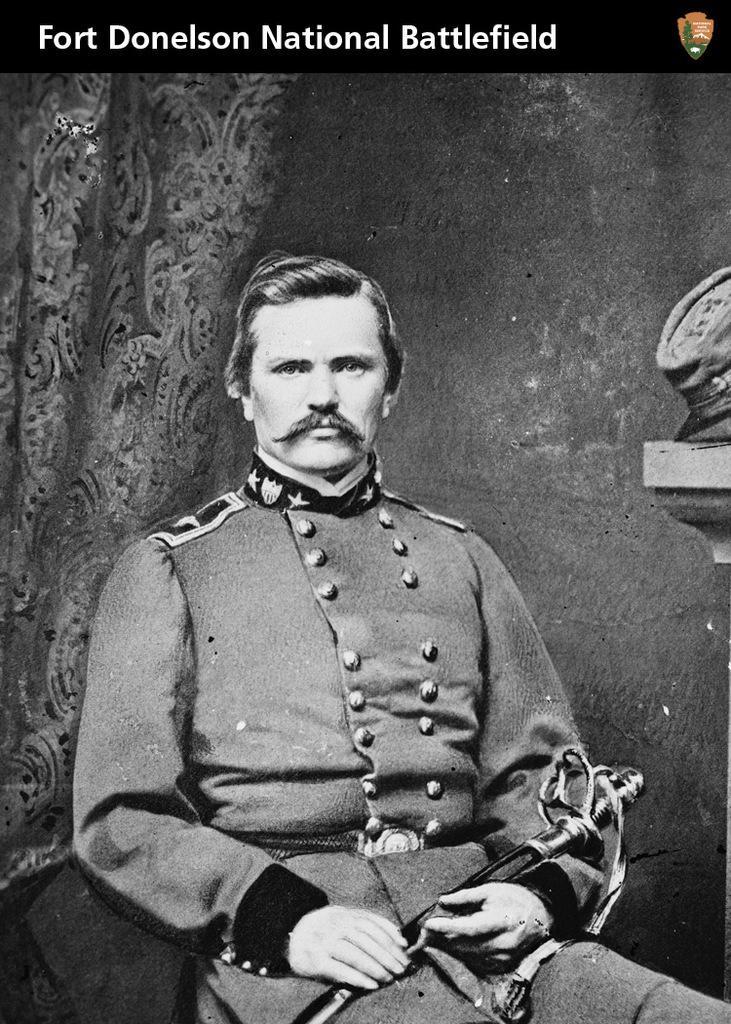Describe this image in one or two sentences. This is an black and white poster of a man. He wore a uniform. This man holds a sword. This poster is titled as "Fort Donelson National Battlefield". 